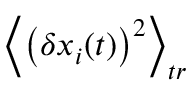<formula> <loc_0><loc_0><loc_500><loc_500>\left \langle \left ( \delta x _ { i } ( t ) \right ) ^ { 2 } \right \rangle _ { t r }</formula> 